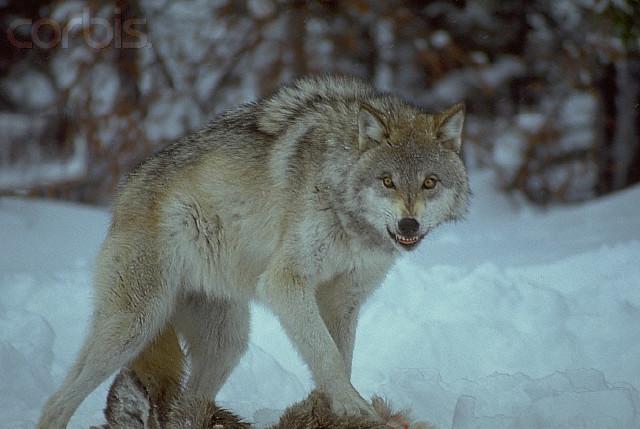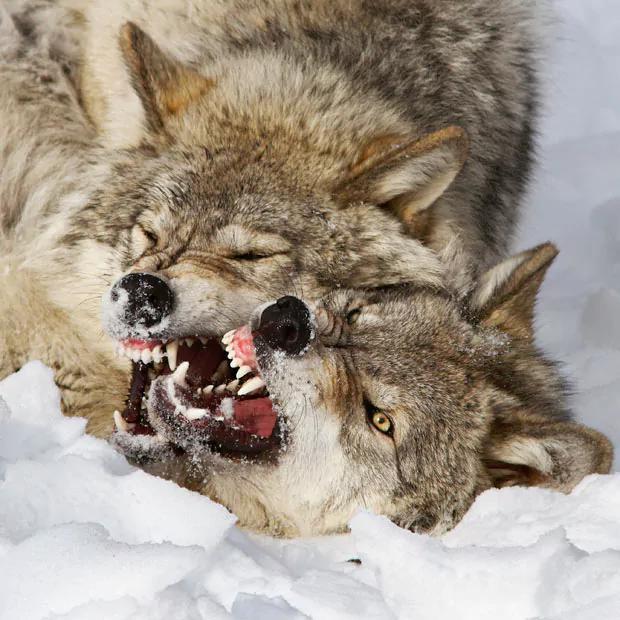The first image is the image on the left, the second image is the image on the right. Analyze the images presented: Is the assertion "All of the wolves are on the snow." valid? Answer yes or no. Yes. The first image is the image on the left, the second image is the image on the right. Analyze the images presented: Is the assertion "One image contains no more than one wolf." valid? Answer yes or no. Yes. 